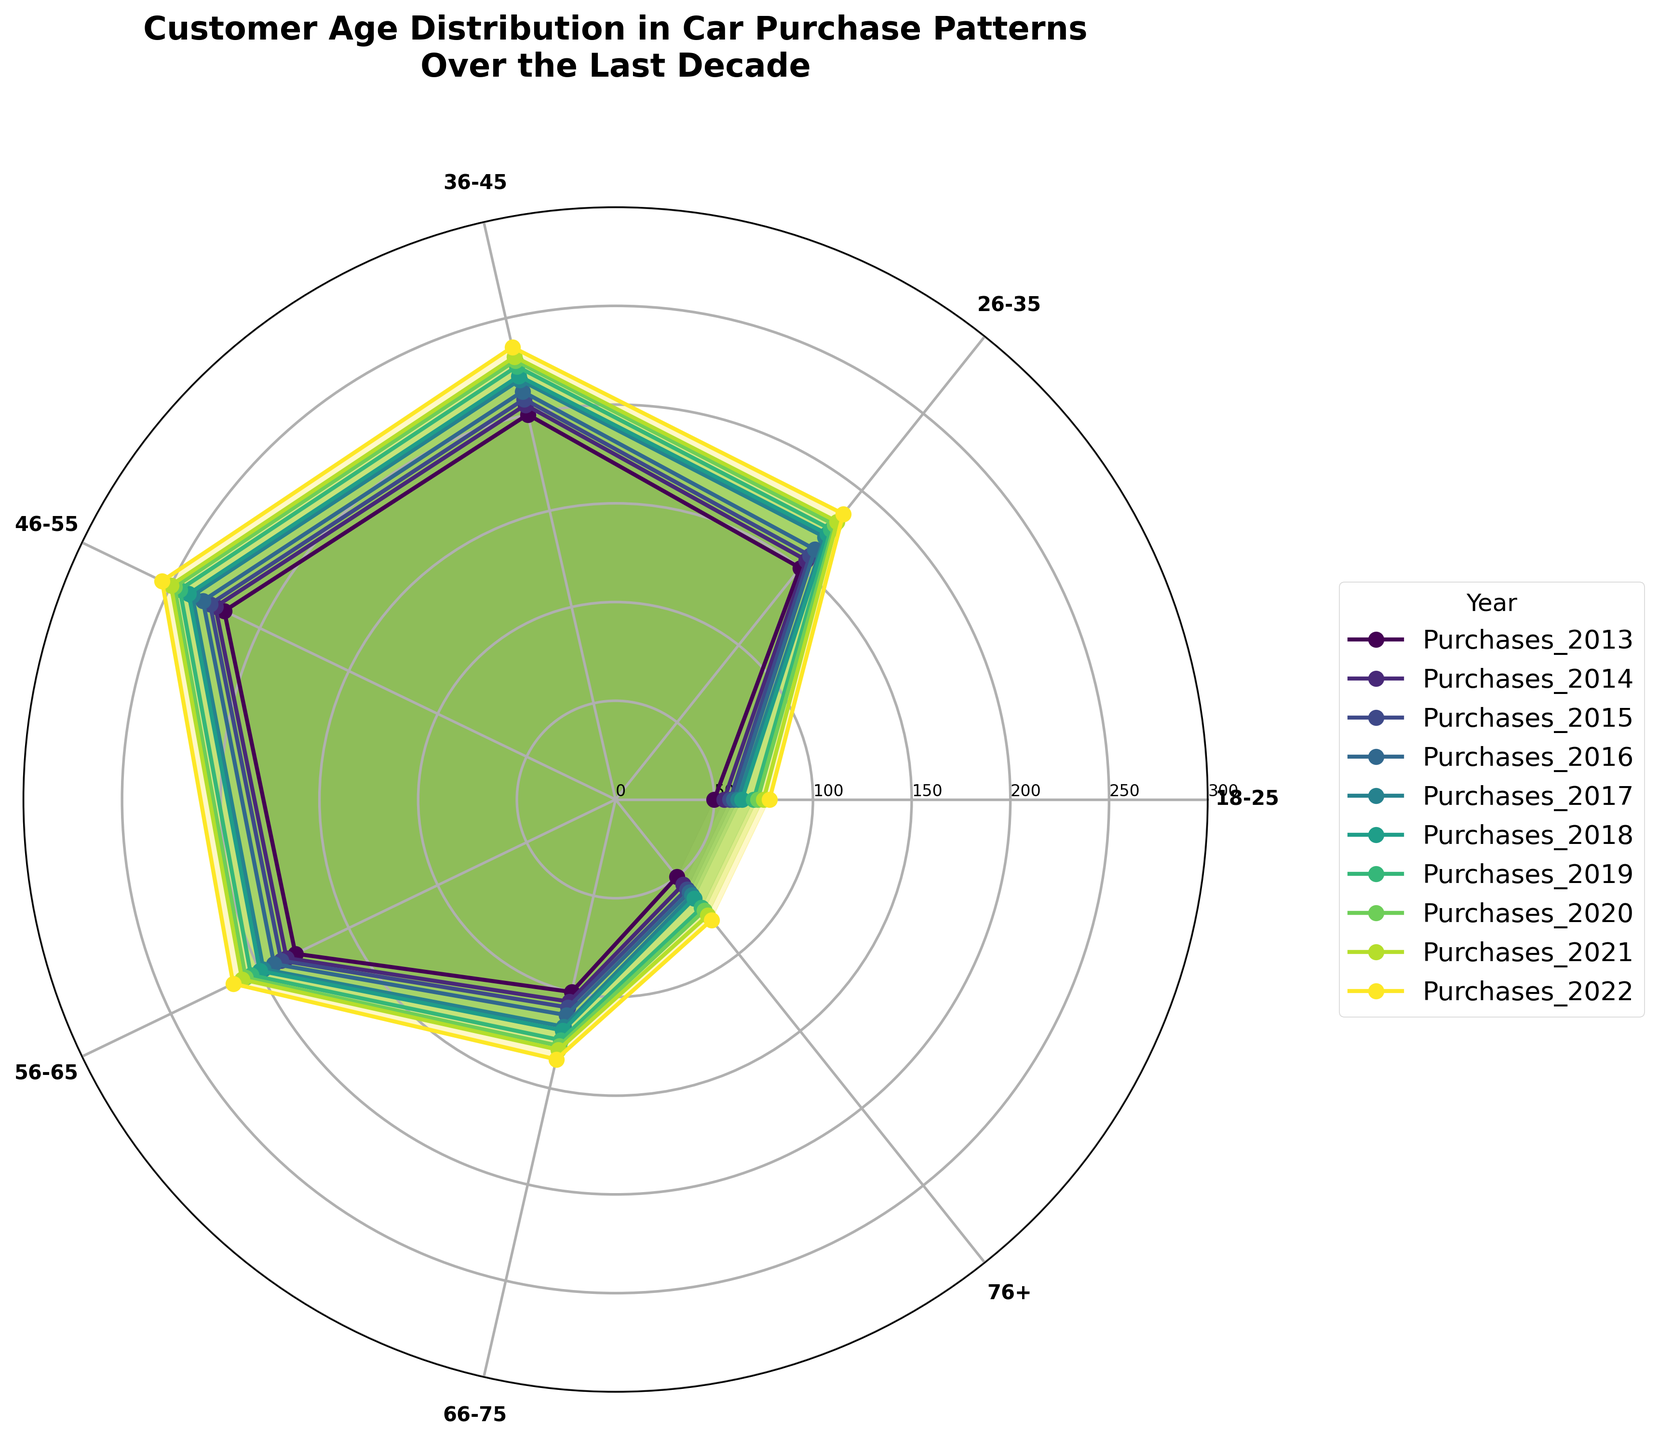How many age groups are displayed in the plot? Count the number of unique labels on the outer ring of the polar chart to determine the number of age groups.
Answer: 7 Which age group had the least number of car purchases in 2022? Identify the year 2022 in the legend, trace its color to the corresponding plot lines, and find the age group with the lowest point on the chart.
Answer: 18-25 and 76+ Is there an age group that has consistently had increasing purchases every year? For each age group, follow their plotted line from 2013 to 2022 and check if there is a continuous upward trend without any decreases.
Answer: Yes, all except 18-25 and 76+ In which year did the 36-45 age group see the highest number of car purchases? Locate the line for the 36-45 age group on the polar chart, and check the highest point's label, then find the corresponding year in the legend.
Answer: 2022 Which age group showed the smallest increase in car purchases from 2013 to 2022? Calculate the difference between the 2022 and 2013 purchases for each age group by comparing their positions on the plot and identifying the smallest increment.
Answer: 18-25 and 76+ What is the average number of car purchases for the 56-65 age group over the last decade? Add the car purchases for the 56-65 age group from 2013 to 2022 and then divide by 10.
Answer: 193.4 Between 46-55 and 36-45 age groups, which had more car purchases in 2017? Compare the points for the 46-55 and 36-45 age groups in the 2017 plot and identify which is higher.
Answer: 46-55 Do purchases for the 66-75 age group in 2018 exceed those for the 18-25 age group in 2022? Compare the heights of the 66-75 age group in 2018 with the 18-25 age group in 2022 on the polar chart.
Answer: Yes What is the percentage increase in car purchases for the 26-35 age group from 2013 to 2017? Calculate the difference in purchases from 2013 to 2017 for the 26-35 age group, divide by the 2013 value, and multiply by 100. For 2013 purchases = 150 and 2017 purchases = 170, the formula is ((170-150)/150) * 100
Answer: 13.33% Which age group has the most scattered data points across the decade? Look for the age group with the most variable plot line, indicating the most fluctuation in purchase patterns.
Answer: 18-25 and 76+ 